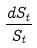<formula> <loc_0><loc_0><loc_500><loc_500>\frac { d S _ { t } } { S _ { t } }</formula> 